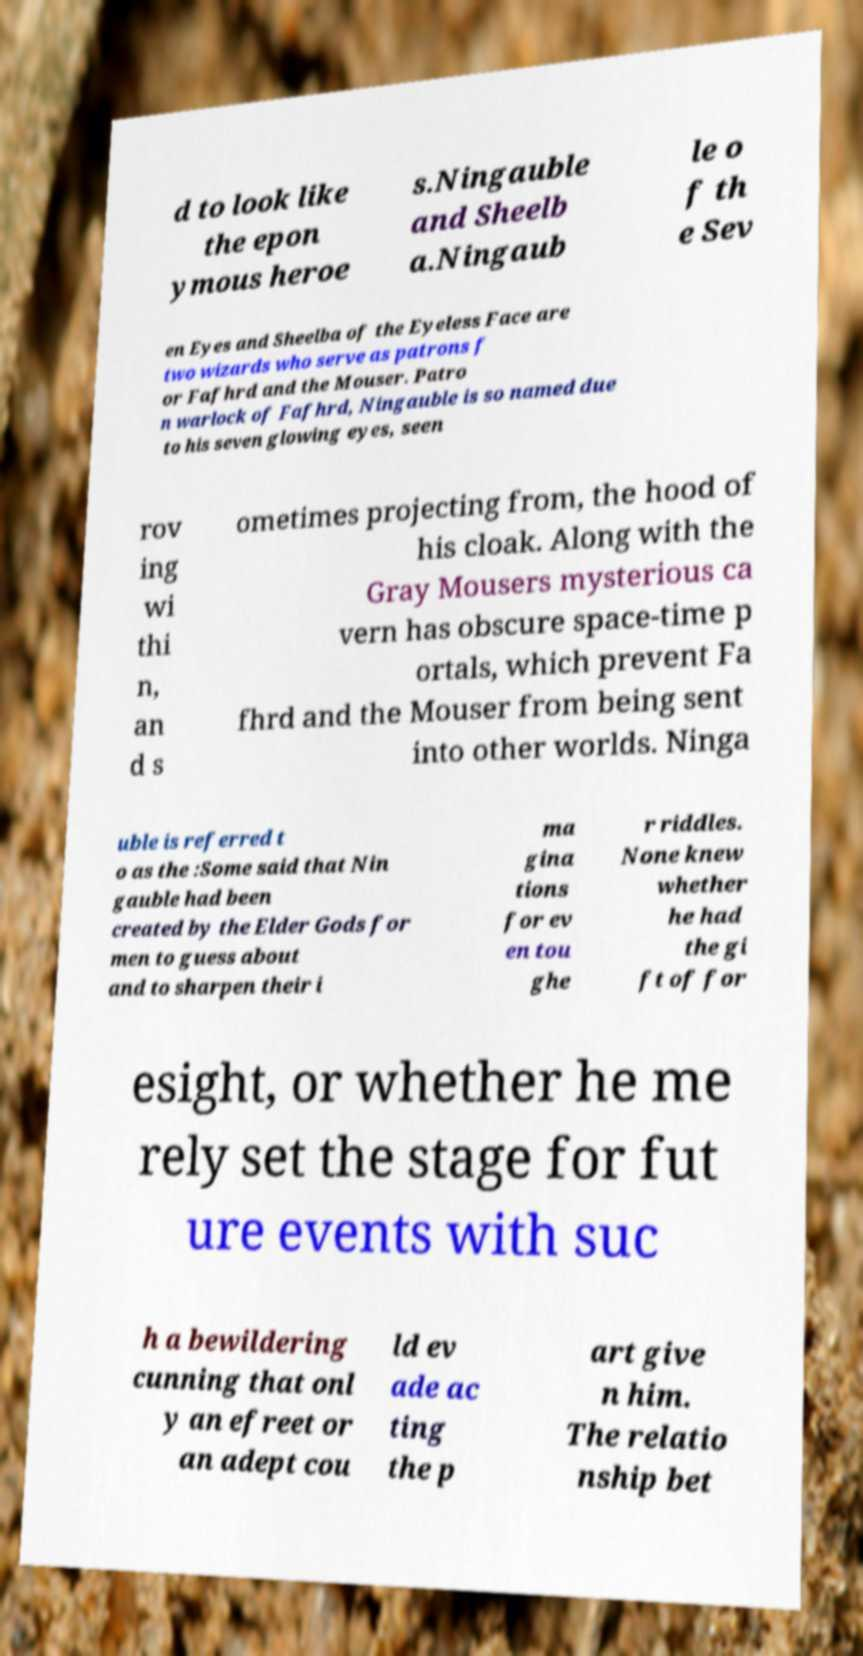Could you extract and type out the text from this image? d to look like the epon ymous heroe s.Ningauble and Sheelb a.Ningaub le o f th e Sev en Eyes and Sheelba of the Eyeless Face are two wizards who serve as patrons f or Fafhrd and the Mouser. Patro n warlock of Fafhrd, Ningauble is so named due to his seven glowing eyes, seen rov ing wi thi n, an d s ometimes projecting from, the hood of his cloak. Along with the Gray Mousers mysterious ca vern has obscure space-time p ortals, which prevent Fa fhrd and the Mouser from being sent into other worlds. Ninga uble is referred t o as the :Some said that Nin gauble had been created by the Elder Gods for men to guess about and to sharpen their i ma gina tions for ev en tou ghe r riddles. None knew whether he had the gi ft of for esight, or whether he me rely set the stage for fut ure events with suc h a bewildering cunning that onl y an efreet or an adept cou ld ev ade ac ting the p art give n him. The relatio nship bet 